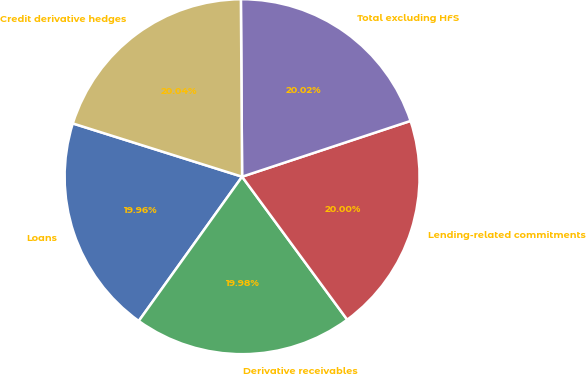Convert chart to OTSL. <chart><loc_0><loc_0><loc_500><loc_500><pie_chart><fcel>Loans<fcel>Derivative receivables<fcel>Lending-related commitments<fcel>Total excluding HFS<fcel>Credit derivative hedges<nl><fcel>19.96%<fcel>19.98%<fcel>20.0%<fcel>20.02%<fcel>20.04%<nl></chart> 